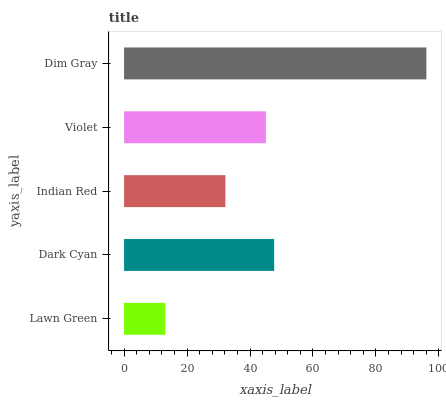Is Lawn Green the minimum?
Answer yes or no. Yes. Is Dim Gray the maximum?
Answer yes or no. Yes. Is Dark Cyan the minimum?
Answer yes or no. No. Is Dark Cyan the maximum?
Answer yes or no. No. Is Dark Cyan greater than Lawn Green?
Answer yes or no. Yes. Is Lawn Green less than Dark Cyan?
Answer yes or no. Yes. Is Lawn Green greater than Dark Cyan?
Answer yes or no. No. Is Dark Cyan less than Lawn Green?
Answer yes or no. No. Is Violet the high median?
Answer yes or no. Yes. Is Violet the low median?
Answer yes or no. Yes. Is Dim Gray the high median?
Answer yes or no. No. Is Lawn Green the low median?
Answer yes or no. No. 